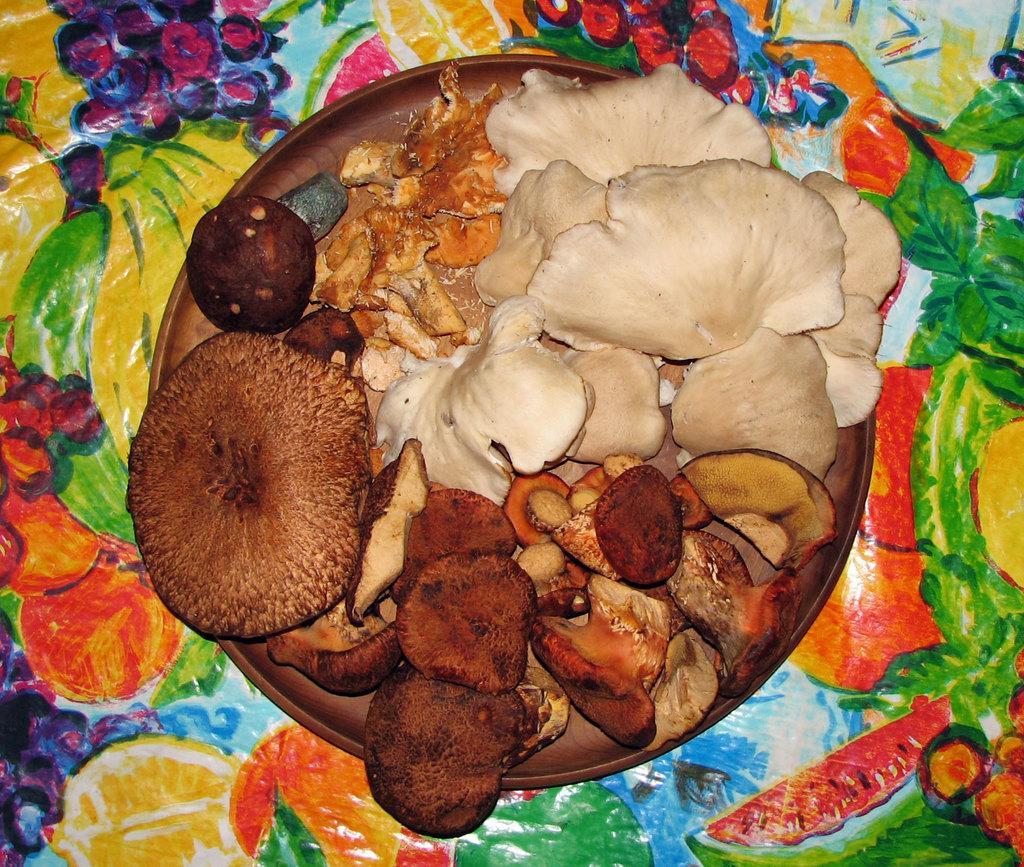Please provide a concise description of this image. In this picture, we see a plate containing the mushrooms and some other eatables is placed on the table. This table is covered with a colorful sheet. 